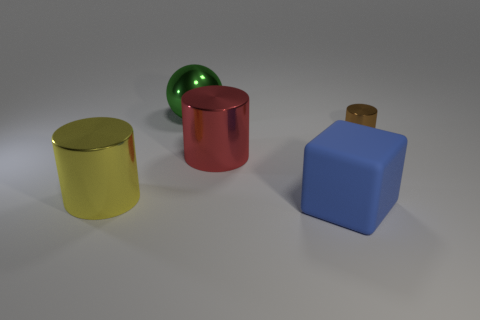What is the size of the metal cylinder to the right of the large red shiny object?
Give a very brief answer. Small. Is there a small brown shiny object to the right of the metal thing to the right of the block?
Ensure brevity in your answer.  No. What number of other objects are there of the same shape as the red metallic object?
Provide a short and direct response. 2. Is the brown metallic thing the same shape as the large green metallic object?
Your response must be concise. No. There is a object that is both to the left of the small brown cylinder and behind the big red shiny cylinder; what is its color?
Your answer should be very brief. Green. How many large objects are cubes or green rubber cylinders?
Offer a very short reply. 1. Are there any other things that are the same color as the ball?
Provide a short and direct response. No. There is a large object that is in front of the metal cylinder on the left side of the large metallic thing that is behind the big red object; what is it made of?
Provide a succinct answer. Rubber. How many rubber objects are either large cyan cylinders or blue cubes?
Provide a succinct answer. 1. How many cyan objects are either large metal things or large metallic cylinders?
Provide a succinct answer. 0. 